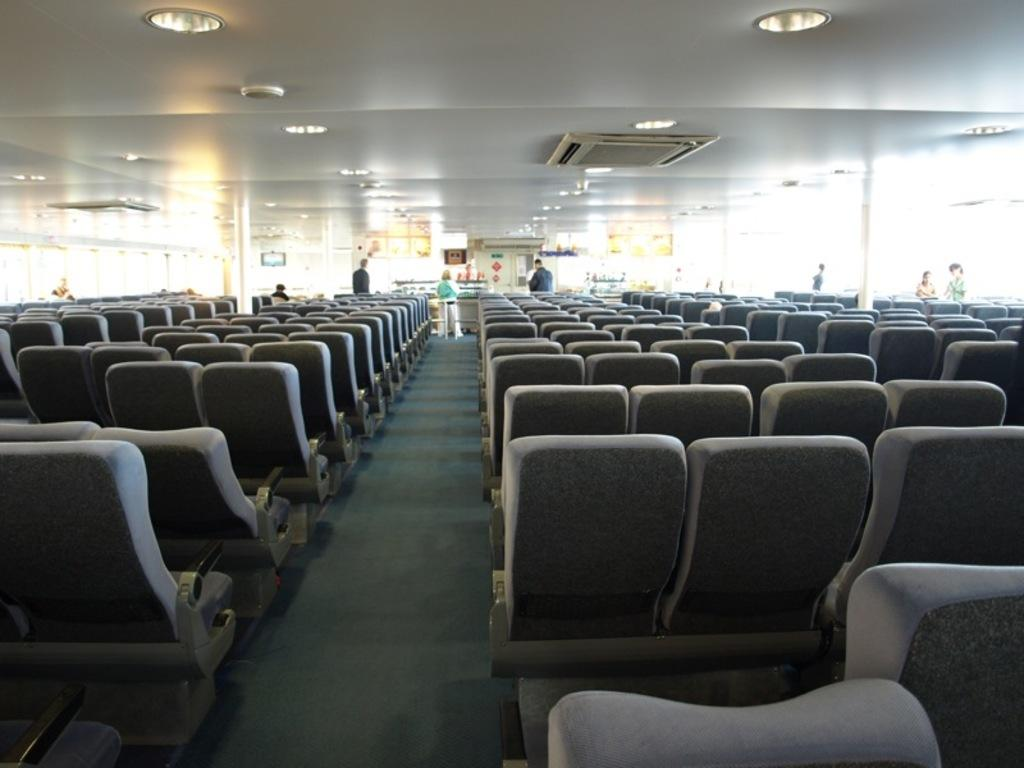What type of furniture is present in the image? There are chairs in the image. Can you describe the people in the image? There are people in the image. What are the people interacting with in the image? There are objects in front of the people. What can be seen at the top of the image? There are lights visible at the top of the image. What type of winter clothing are the people wearing in the image? There is no mention of winter clothing or any specific season in the image, so it cannot be determined from the image. How many sea creatures can be seen in the image? There are no sea creatures present in the image. 